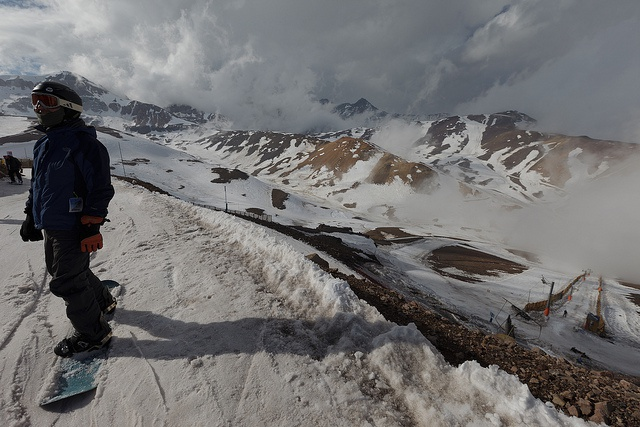Describe the objects in this image and their specific colors. I can see people in gray, black, darkgray, and maroon tones, snowboard in gray, black, darkgray, and purple tones, and people in gray and black tones in this image. 